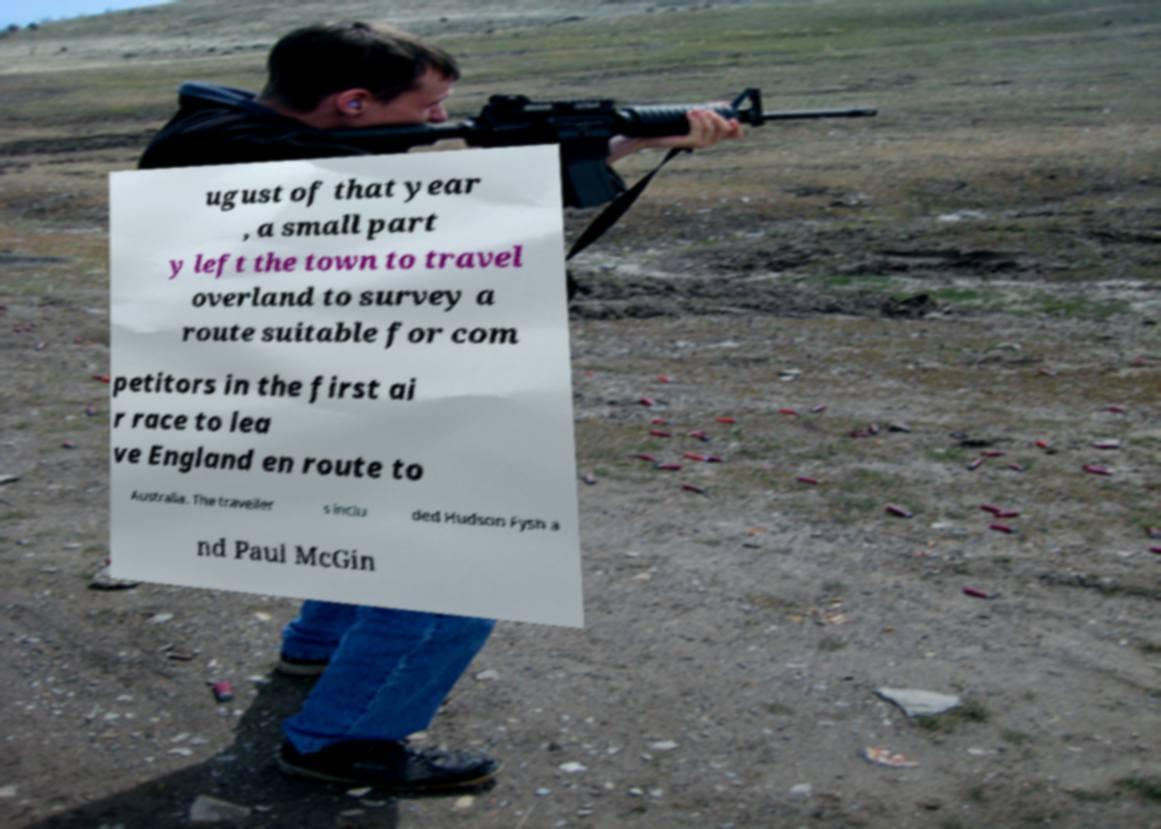Could you extract and type out the text from this image? ugust of that year , a small part y left the town to travel overland to survey a route suitable for com petitors in the first ai r race to lea ve England en route to Australia. The traveller s inclu ded Hudson Fysh a nd Paul McGin 